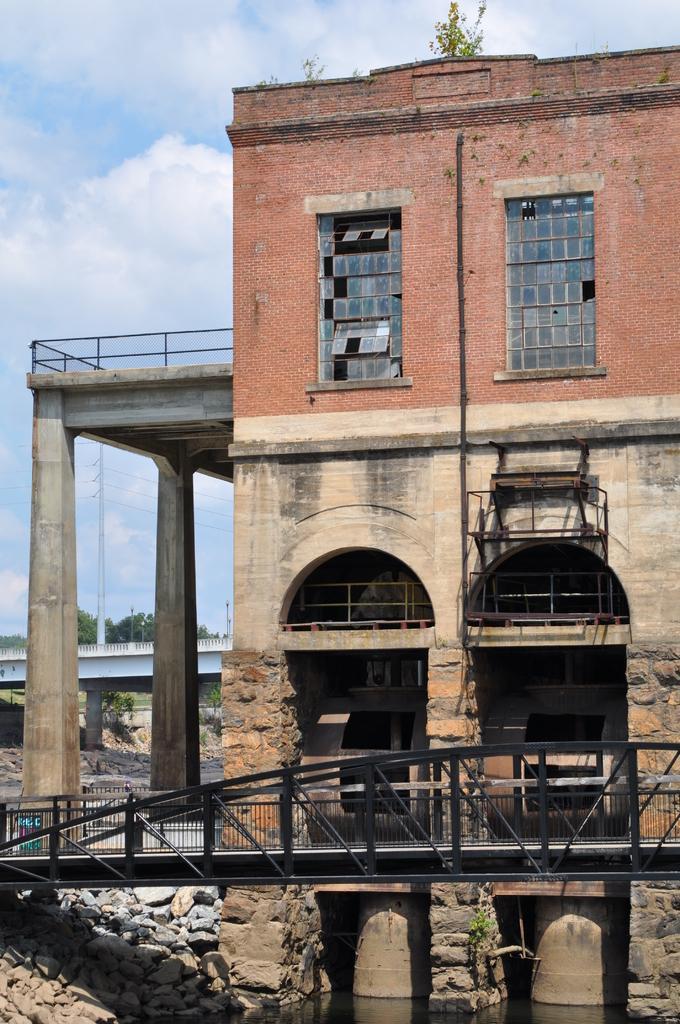In one or two sentences, can you explain what this image depicts? As we can see in the image there is a building, windows, bridgewater, rocks, sky and clouds. 